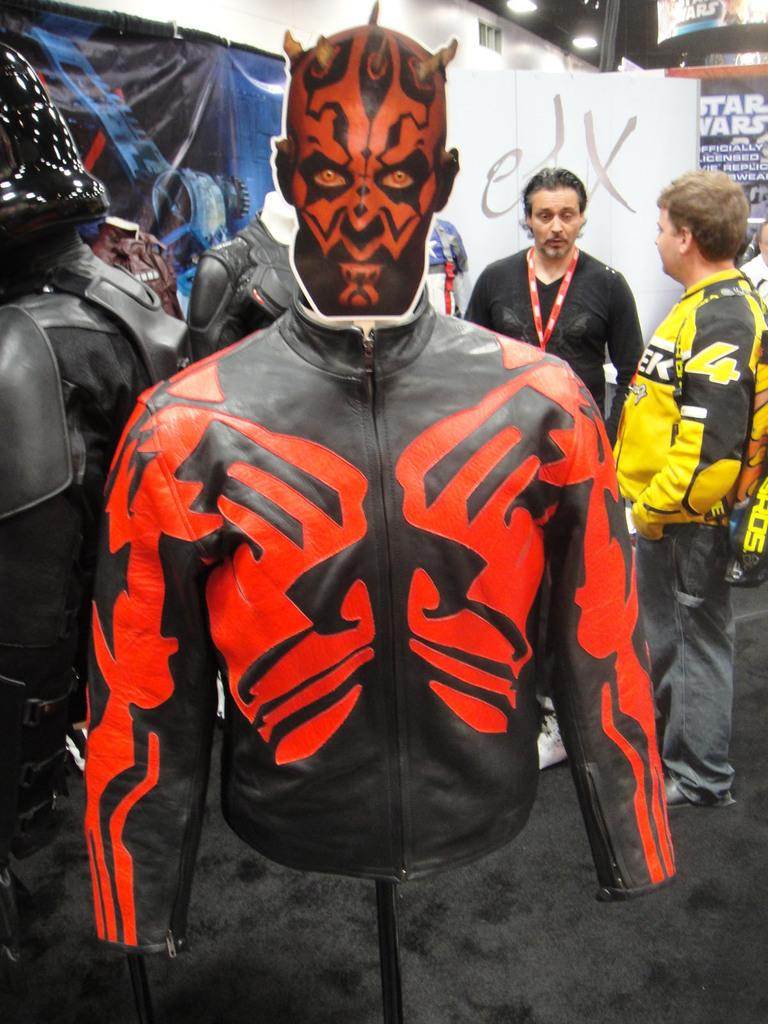What is located in the foreground of the image? There is a jacket in the foreground of the image. What can be seen in the background of the image? There are people in the background of the image. What is the banner in the image used for? The purpose of the banner in the image is not specified, but it could be for advertising, promotion, or decoration. What is at the bottom of the image? There is a carpet at the bottom of the image. What type of hook is attached to the jacket in the image? There is no hook visible on the jacket in the image. 